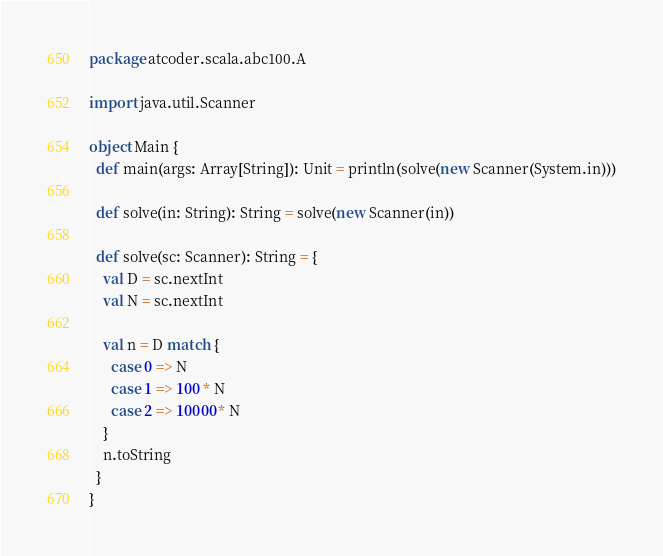<code> <loc_0><loc_0><loc_500><loc_500><_Scala_>package atcoder.scala.abc100.A

import java.util.Scanner

object Main {
  def main(args: Array[String]): Unit = println(solve(new Scanner(System.in)))

  def solve(in: String): String = solve(new Scanner(in))

  def solve(sc: Scanner): String = {
    val D = sc.nextInt
    val N = sc.nextInt

    val n = D match {
      case 0 => N
      case 1 => 100 * N
      case 2 => 10000 * N
    }
    n.toString
  }
}
</code> 